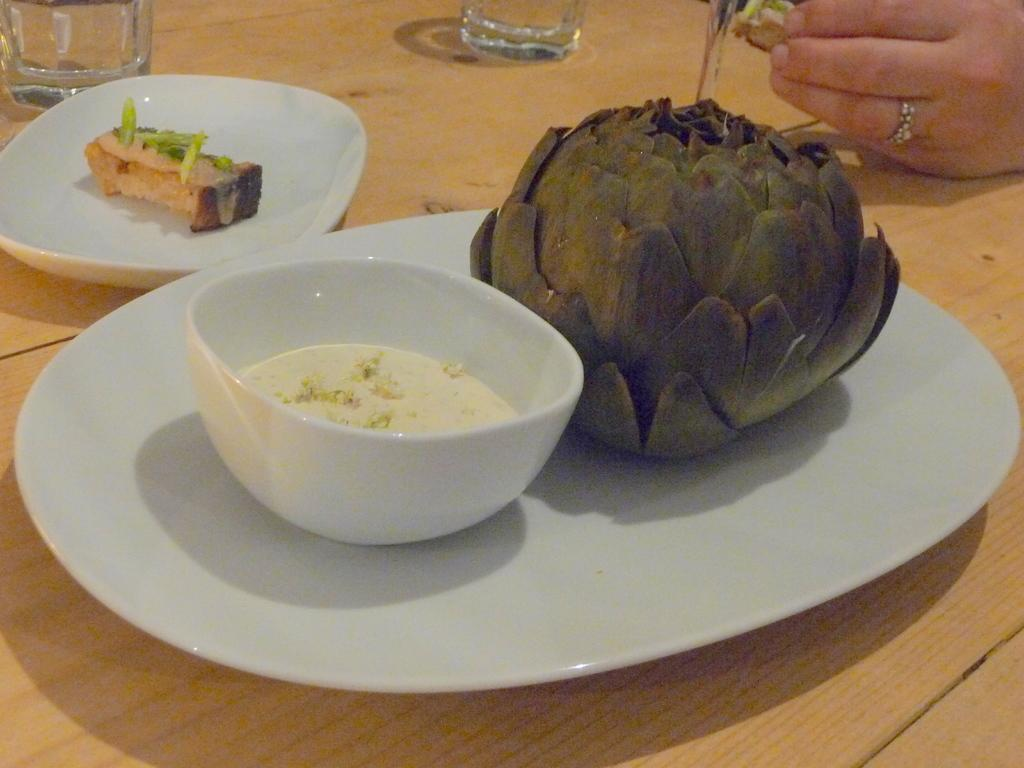What is on the white plate in the image? There are food items on a white plate in the image. What else can be seen in the image besides the plate? There is a bowl in the image. Can you describe the person's hand visible on the right side of the image? A person's hand is visible on the right side of the image. What objects can be seen in the background of the image? There are glasses in the background of the image. Are there any dinosaurs visible in the image? No, there are no dinosaurs present in the image. What letter is written on the food items in the image? There is no letter written on the food items in the image. 